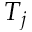Convert formula to latex. <formula><loc_0><loc_0><loc_500><loc_500>T _ { j }</formula> 